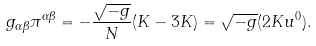Convert formula to latex. <formula><loc_0><loc_0><loc_500><loc_500>g _ { \alpha \beta } \pi ^ { \alpha \beta } = - \frac { \sqrt { - g } } { N } ( K - 3 K ) = \sqrt { - g } ( 2 K u ^ { 0 } ) .</formula> 